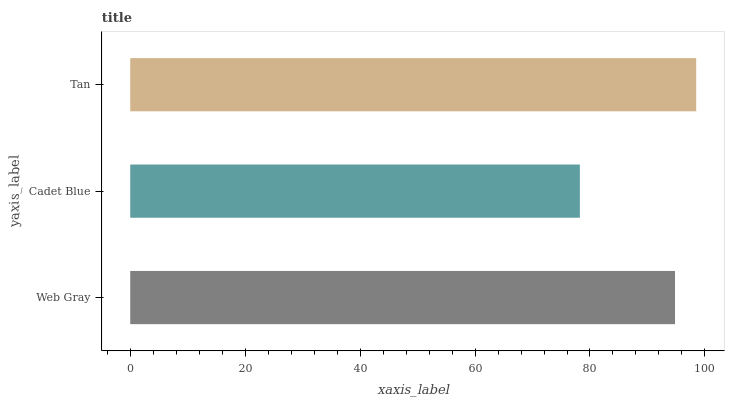Is Cadet Blue the minimum?
Answer yes or no. Yes. Is Tan the maximum?
Answer yes or no. Yes. Is Tan the minimum?
Answer yes or no. No. Is Cadet Blue the maximum?
Answer yes or no. No. Is Tan greater than Cadet Blue?
Answer yes or no. Yes. Is Cadet Blue less than Tan?
Answer yes or no. Yes. Is Cadet Blue greater than Tan?
Answer yes or no. No. Is Tan less than Cadet Blue?
Answer yes or no. No. Is Web Gray the high median?
Answer yes or no. Yes. Is Web Gray the low median?
Answer yes or no. Yes. Is Tan the high median?
Answer yes or no. No. Is Cadet Blue the low median?
Answer yes or no. No. 